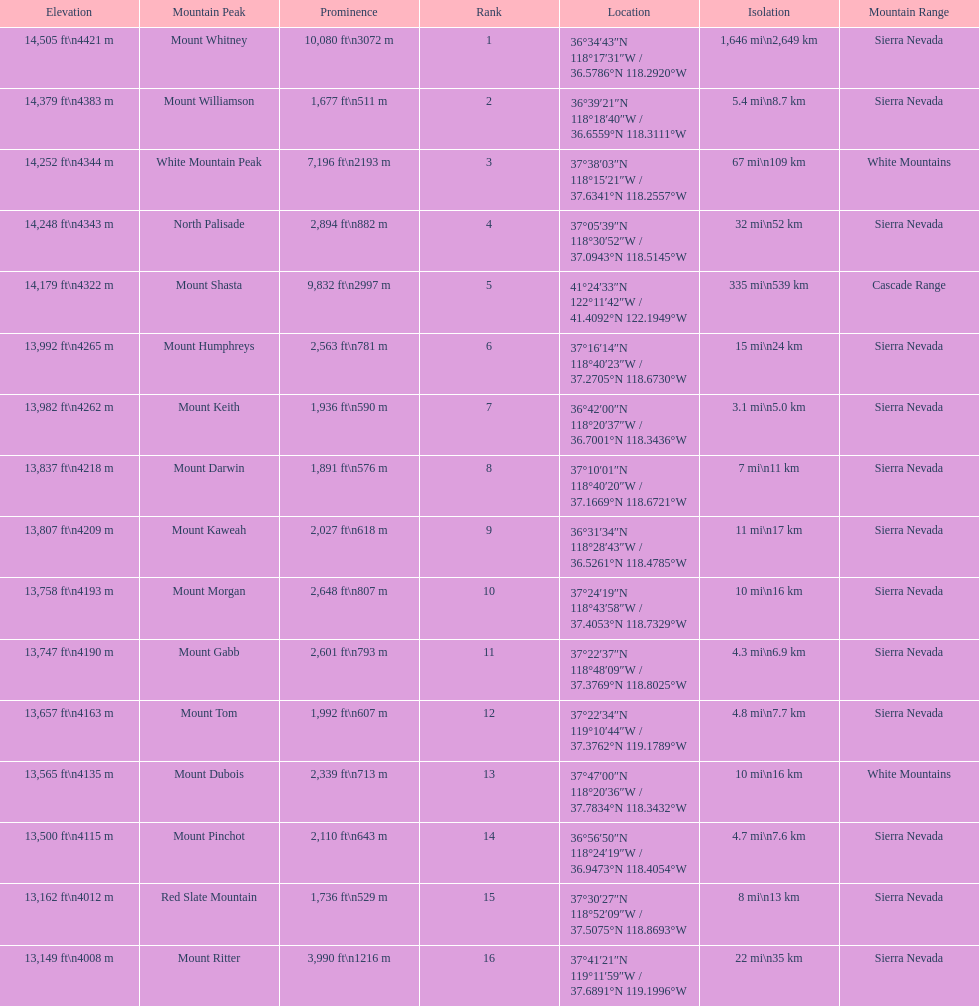What is the total elevation (in ft) of mount whitney? 14,505 ft. 